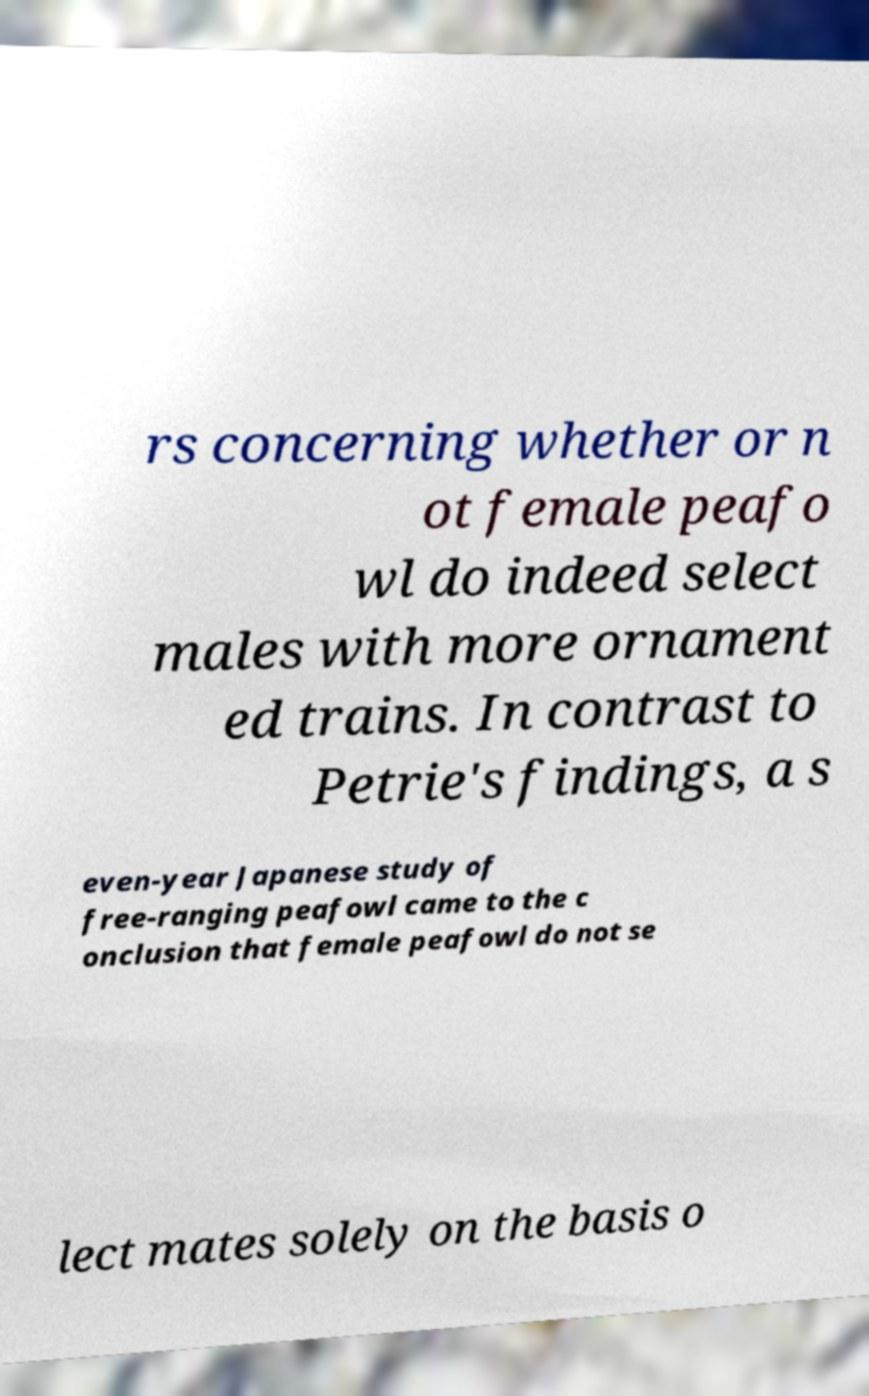Could you assist in decoding the text presented in this image and type it out clearly? rs concerning whether or n ot female peafo wl do indeed select males with more ornament ed trains. In contrast to Petrie's findings, a s even-year Japanese study of free-ranging peafowl came to the c onclusion that female peafowl do not se lect mates solely on the basis o 